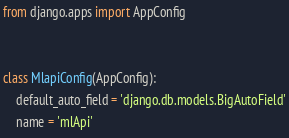<code> <loc_0><loc_0><loc_500><loc_500><_Python_>from django.apps import AppConfig


class MlapiConfig(AppConfig):
    default_auto_field = 'django.db.models.BigAutoField'
    name = 'mlApi'
</code> 